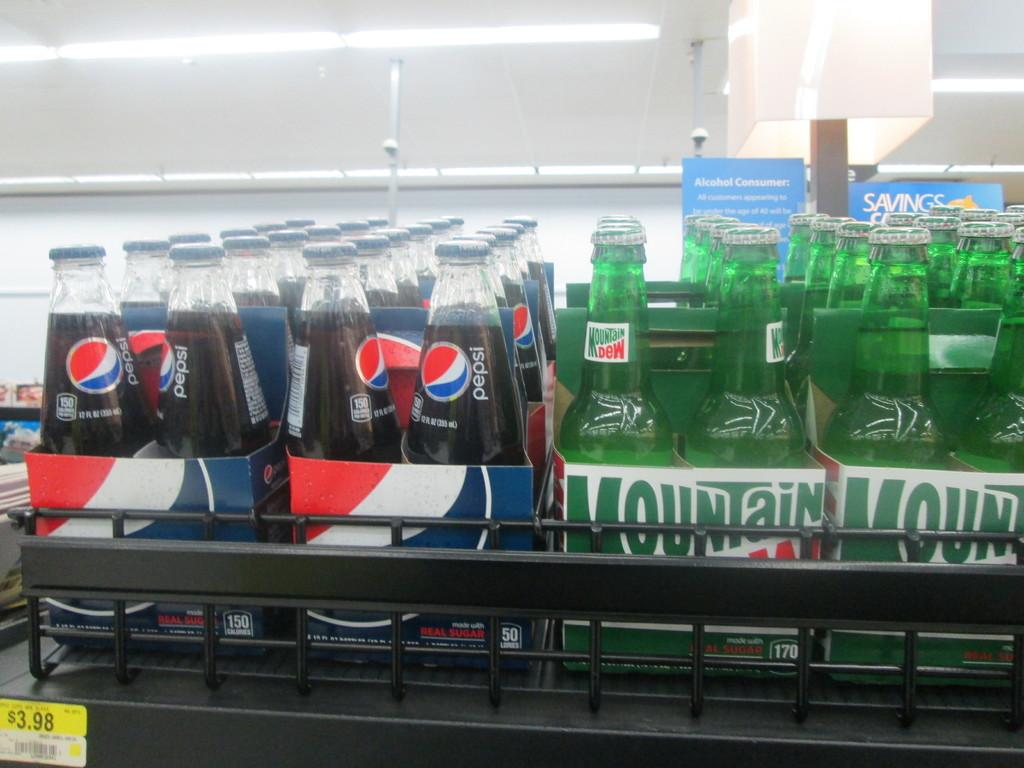Provide a one-sentence caption for the provided image. Two different brands of beverages with one being Pepsi and the other being Mountain Dew. 